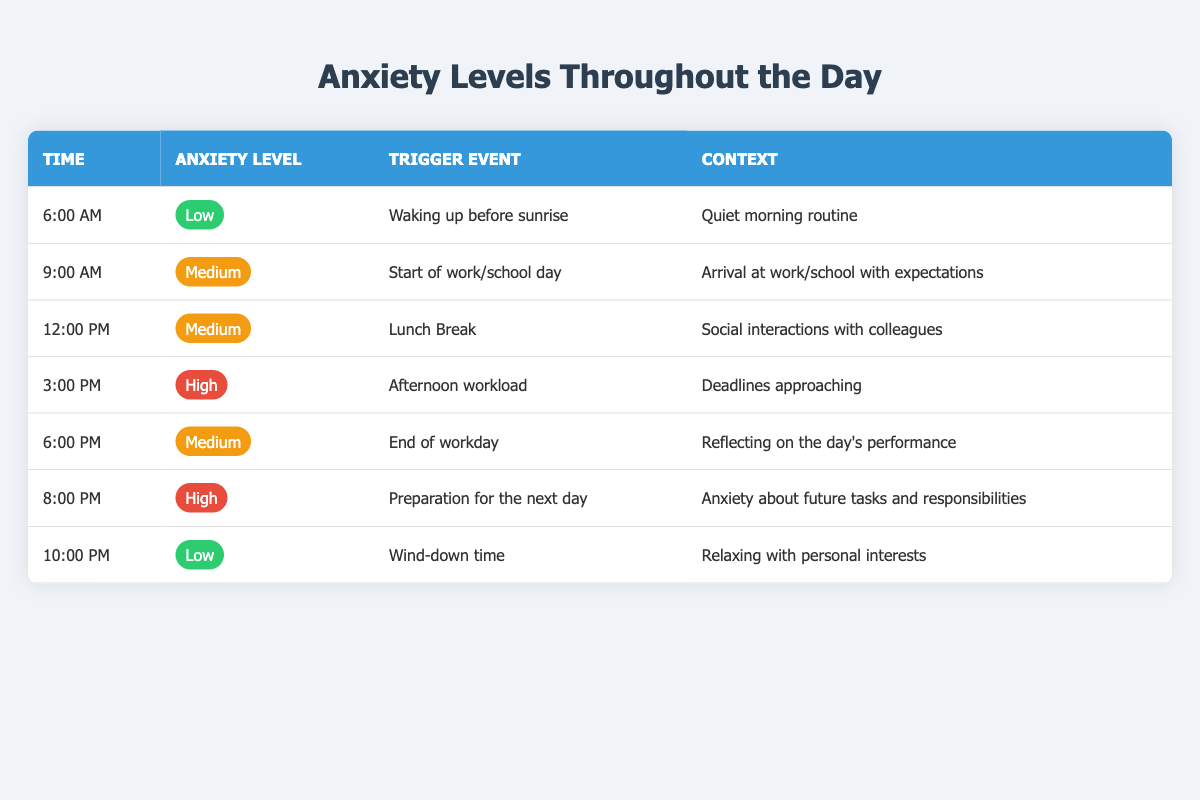What is the anxiety level at 6:00 AM? According to the table, the anxiety level at 6:00 AM is specified as "Low."
Answer: Low What are the trigger events for the 3:00 PM hour? The table indicates that the trigger event for 3:00 PM is "Afternoon workload."
Answer: Afternoon workload How many times during the day is the anxiety level considered high? The table shows high anxiety levels at 3:00 PM and 8:00 PM, which totals 2 times during the day.
Answer: 2 Is the anxiety level at 9:00 AM higher than at 12:00 PM? The anxiety level at 9:00 AM is "Medium," and it is the same at 12:00 PM, therefore it is not higher.
Answer: No What is the context for the anxiety level "High" at 8:00 PM? According to the table, the context for the anxiety level "High" at 8:00 PM is "Anxiety about future tasks and responsibilities."
Answer: Anxiety about future tasks and responsibilities What is the average anxiety level throughout the day? The levels are Low, Medium, Medium, High, Medium, High, and Low. Assigning numerical values (Low=1, Medium=2, High=3), we get (1 + 2 + 2 + 3 + 2 + 3 + 1) = 14. There are 7 data points, so the average is 14/7 = 2.
Answer: 2 How does the anxiety level at 6:00 PM compare with that at 3:00 PM? The anxiety level at 6:00 PM is "Medium," while at 3:00 PM it is "High." Therefore, 6:00 PM is lower.
Answer: Lower What time shows the lowest anxiety level? The lowest anxiety level according to the table occurs at 6:00 AM and 10:00 PM, where both are classified as "Low."
Answer: 6:00 AM and 10:00 PM 